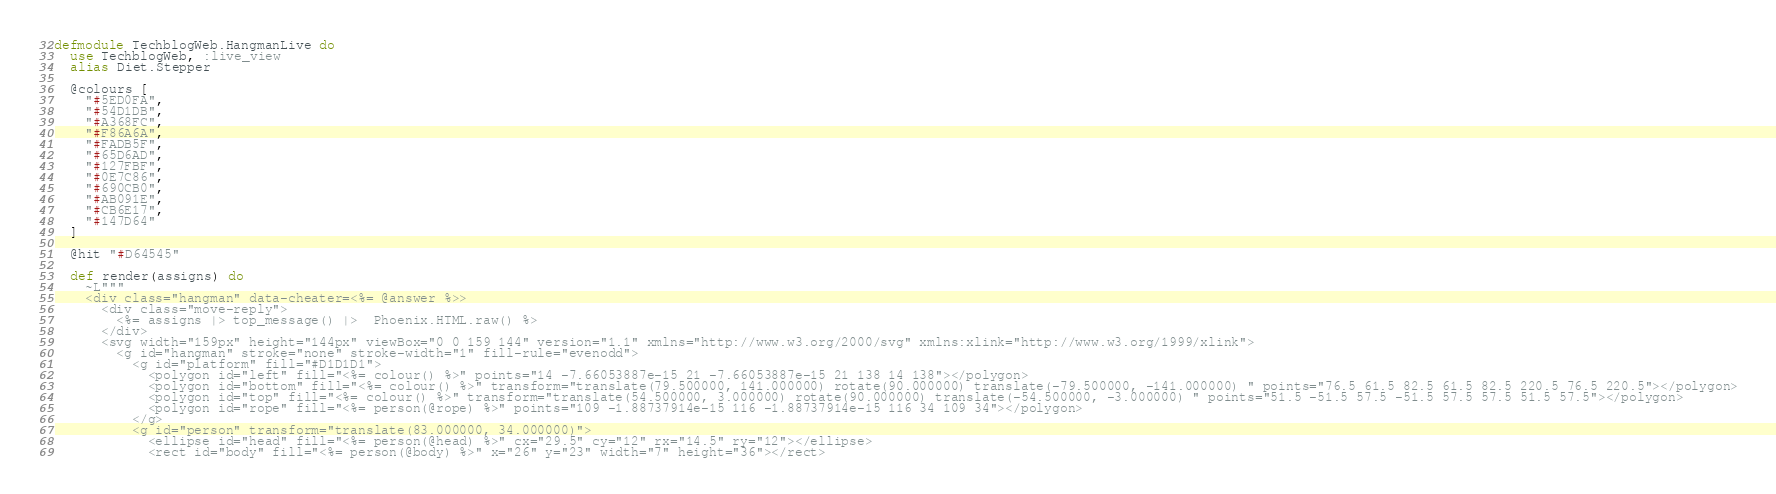Convert code to text. <code><loc_0><loc_0><loc_500><loc_500><_Elixir_>defmodule TechblogWeb.HangmanLive do
  use TechblogWeb, :live_view
  alias Diet.Stepper

  @colours [
    "#5ED0FA",
    "#54D1DB",
    "#A368FC",
    "#F86A6A",
    "#FADB5F",
    "#65D6AD",
    "#127FBF",
    "#0E7C86",
    "#690CB0",
    "#AB091E",
    "#CB6E17",
    "#147D64"
  ]

  @hit "#D64545"

  def render(assigns) do
    ~L"""
    <div class="hangman" data-cheater=<%= @answer %>>
      <div class="move-reply">
        <%= assigns |> top_message() |>  Phoenix.HTML.raw() %>
      </div>
      <svg width="159px" height="144px" viewBox="0 0 159 144" version="1.1" xmlns="http://www.w3.org/2000/svg" xmlns:xlink="http://www.w3.org/1999/xlink">
        <g id="hangman" stroke="none" stroke-width="1" fill-rule="evenodd">
          <g id="platform" fill="#D1D1D1">
            <polygon id="left" fill="<%= colour() %>" points="14 -7.66053887e-15 21 -7.66053887e-15 21 138 14 138"></polygon>
            <polygon id="bottom" fill="<%= colour() %>" transform="translate(79.500000, 141.000000) rotate(90.000000) translate(-79.500000, -141.000000) " points="76.5 61.5 82.5 61.5 82.5 220.5 76.5 220.5"></polygon>
            <polygon id="top" fill="<%= colour() %>" transform="translate(54.500000, 3.000000) rotate(90.000000) translate(-54.500000, -3.000000) " points="51.5 -51.5 57.5 -51.5 57.5 57.5 51.5 57.5"></polygon>
            <polygon id="rope" fill="<%= person(@rope) %>" points="109 -1.88737914e-15 116 -1.88737914e-15 116 34 109 34"></polygon>
          </g>
          <g id="person" transform="translate(83.000000, 34.000000)">
            <ellipse id="head" fill="<%= person(@head) %>" cx="29.5" cy="12" rx="14.5" ry="12"></ellipse>
            <rect id="body" fill="<%= person(@body) %>" x="26" y="23" width="7" height="36"></rect></code> 